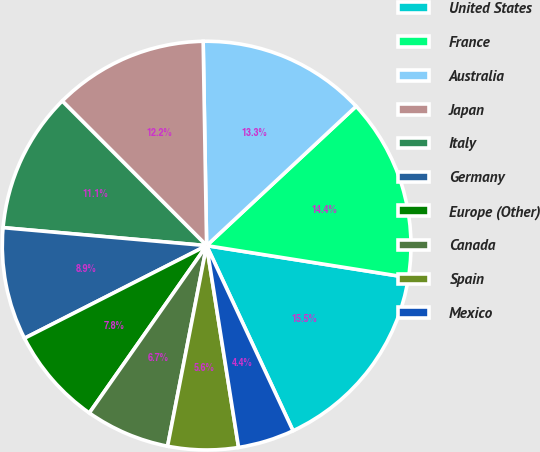Convert chart. <chart><loc_0><loc_0><loc_500><loc_500><pie_chart><fcel>United States<fcel>France<fcel>Australia<fcel>Japan<fcel>Italy<fcel>Germany<fcel>Europe (Other)<fcel>Canada<fcel>Spain<fcel>Mexico<nl><fcel>15.55%<fcel>14.44%<fcel>13.33%<fcel>12.22%<fcel>11.11%<fcel>8.89%<fcel>7.78%<fcel>6.67%<fcel>5.56%<fcel>4.45%<nl></chart> 